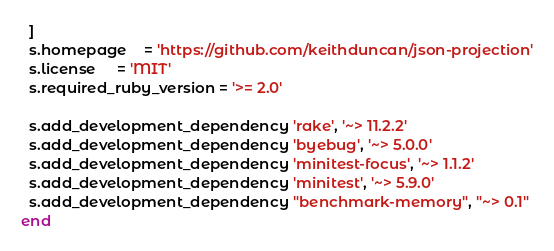<code> <loc_0><loc_0><loc_500><loc_500><_Ruby_>  ]
  s.homepage    = 'https://github.com/keithduncan/json-projection'
  s.license     = 'MIT'
  s.required_ruby_version = '>= 2.0'

  s.add_development_dependency 'rake', '~> 11.2.2'
  s.add_development_dependency 'byebug', '~> 5.0.0'
  s.add_development_dependency 'minitest-focus', '~> 1.1.2'
  s.add_development_dependency 'minitest', '~> 5.9.0'
  s.add_development_dependency "benchmark-memory", "~> 0.1"
end
</code> 